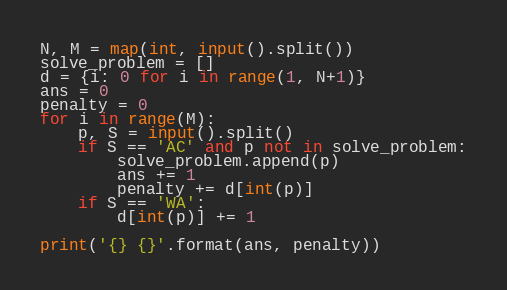<code> <loc_0><loc_0><loc_500><loc_500><_Python_>N, M = map(int, input().split())
solve_problem = []
d = {i: 0 for i in range(1, N+1)}
ans = 0
penalty = 0
for i in range(M):
    p, S = input().split()
    if S == 'AC' and p not in solve_problem:
        solve_problem.append(p)
        ans += 1
        penalty += d[int(p)]
    if S == 'WA':
        d[int(p)] += 1

print('{} {}'.format(ans, penalty))

</code> 